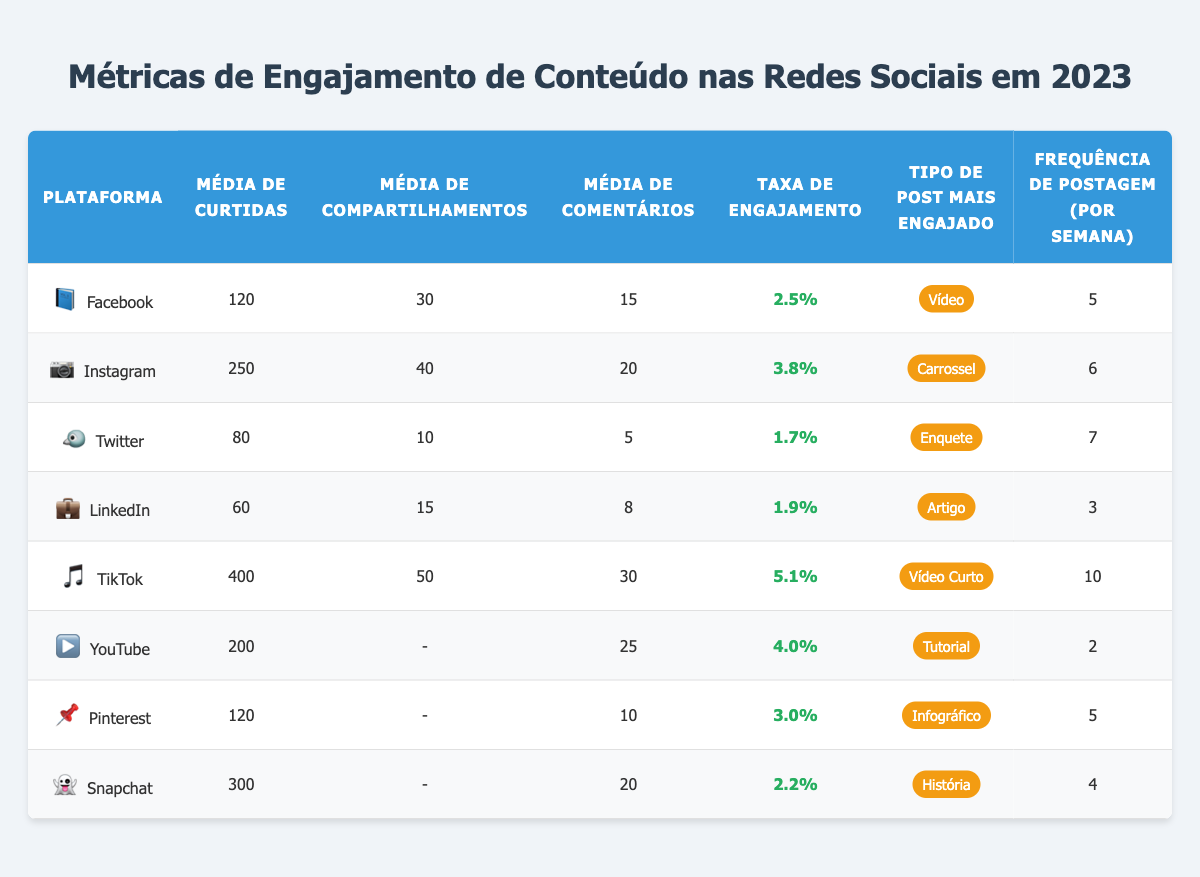Qual é a plataforma com a maior taxa de engajamento? Analisando a coluna "Taxa de Engajamento", a plataforma TikTok tem a maior taxa, que é de 5.1%.
Answer: TikTok Qual é a frequência de postagem recomendada no Instagram? O Instagram possui uma frequência de postagem de 6 vezes por semana, conforme a tabela.
Answer: 6 Qual é o tipo de post mais engajado no Facebook? A tabela indica que o tipo de post mais engajado no Facebook é "Vídeo".
Answer: Vídeo Quantas curtidas em média os posts do LinkedIn recebem? Na tabela, a média de curtidas por post no LinkedIn é de 60.
Answer: 60 Qual é a média de comentários por post no TikTok? De acordo com a tabela, a média de comentários por vídeo no TikTok é 30.
Answer: 30 Qual plataforma tem a menor média de comentários por post? O LinkedIn tem a menor média de comentários por post, que é 8, enquanto as outras plataformas possuem números superiores.
Answer: LinkedIn Qual é a soma das médias de curtidas por post em Facebook e Pinterest? A média de curtidas no Facebook é 120 e no Pinterest é 120. Somando, temos 120 + 120 = 240.
Answer: 240 O que é maior, a média de curtidas no YouTube ou a média de likes no Facebook? A média de curtidas no YouTube é 200, que é maior do que a média de 120 do Facebook. Então, 200 > 120 é verdadeiro.
Answer: Sim Qual plataforma, entre TikTok e YouTube, tem mais compartilhamentos por post? TikTok tem uma média de 50 compartilhamentos por vídeo, enquanto YouTube não possui dados para compartilhamentos; portanto, TikTok é maior.
Answer: TikTok Qual é o engajamento total médio (soma de curtidas, compartilhamentos e comentários) para a plataforma Instagram? Para Instagram: Curtidas (250) + Compartilhamentos (40) + Comentários (20) = 310. Portanto, o engajamento total médio é 310.
Answer: 310 Quantas plataformas têm uma taxa de engajamento superior a 3%? As plataformas com taxa de engajamento superior a 3% são TikTok (5.1%) e Instagram (3.8%), totalizando 2.
Answer: 2 